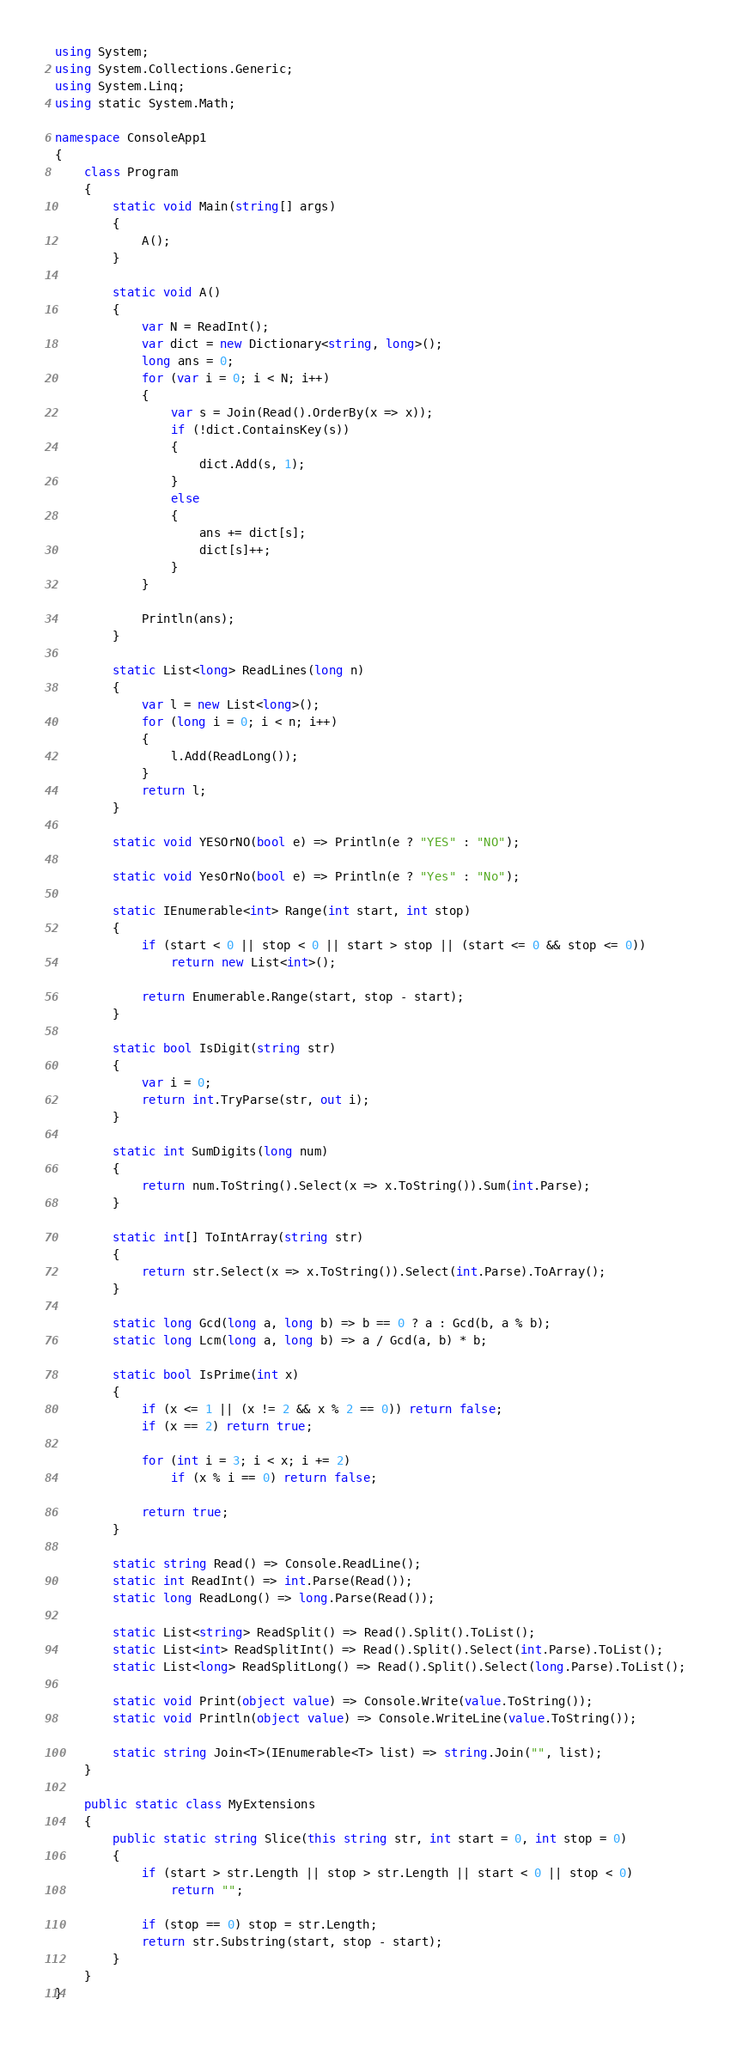<code> <loc_0><loc_0><loc_500><loc_500><_C#_>using System;
using System.Collections.Generic;
using System.Linq;
using static System.Math;

namespace ConsoleApp1
{
    class Program
    {
        static void Main(string[] args)
        {
            A();
        }

        static void A()
        {
            var N = ReadInt();
            var dict = new Dictionary<string, long>();
            long ans = 0;
            for (var i = 0; i < N; i++)
            {
                var s = Join(Read().OrderBy(x => x));
                if (!dict.ContainsKey(s))
                {
                    dict.Add(s, 1);
                }
                else
                {
                    ans += dict[s];
                    dict[s]++;
                }
            }

            Println(ans);
        }

        static List<long> ReadLines(long n)
        {
            var l = new List<long>();
            for (long i = 0; i < n; i++)
            {
                l.Add(ReadLong());
            }
            return l;
        }

        static void YESOrNO(bool e) => Println(e ? "YES" : "NO");

        static void YesOrNo(bool e) => Println(e ? "Yes" : "No");

        static IEnumerable<int> Range(int start, int stop)
        {
            if (start < 0 || stop < 0 || start > stop || (start <= 0 && stop <= 0))
                return new List<int>();

            return Enumerable.Range(start, stop - start);
        }

        static bool IsDigit(string str)
        {
            var i = 0;
            return int.TryParse(str, out i);
        }

        static int SumDigits(long num)
        {
            return num.ToString().Select(x => x.ToString()).Sum(int.Parse);
        }

        static int[] ToIntArray(string str)
        {
            return str.Select(x => x.ToString()).Select(int.Parse).ToArray();
        }

        static long Gcd(long a, long b) => b == 0 ? a : Gcd(b, a % b);
        static long Lcm(long a, long b) => a / Gcd(a, b) * b;

        static bool IsPrime(int x)
        {
            if (x <= 1 || (x != 2 && x % 2 == 0)) return false;
            if (x == 2) return true;

            for (int i = 3; i < x; i += 2)
                if (x % i == 0) return false;

            return true;
        }

        static string Read() => Console.ReadLine();
        static int ReadInt() => int.Parse(Read());
        static long ReadLong() => long.Parse(Read());

        static List<string> ReadSplit() => Read().Split().ToList();
        static List<int> ReadSplitInt() => Read().Split().Select(int.Parse).ToList();
        static List<long> ReadSplitLong() => Read().Split().Select(long.Parse).ToList();

        static void Print(object value) => Console.Write(value.ToString());
        static void Println(object value) => Console.WriteLine(value.ToString());

        static string Join<T>(IEnumerable<T> list) => string.Join("", list);
    }

    public static class MyExtensions
    {
        public static string Slice(this string str, int start = 0, int stop = 0)
        {
            if (start > str.Length || stop > str.Length || start < 0 || stop < 0)
                return "";

            if (stop == 0) stop = str.Length;
            return str.Substring(start, stop - start);
        }
    }
}
</code> 